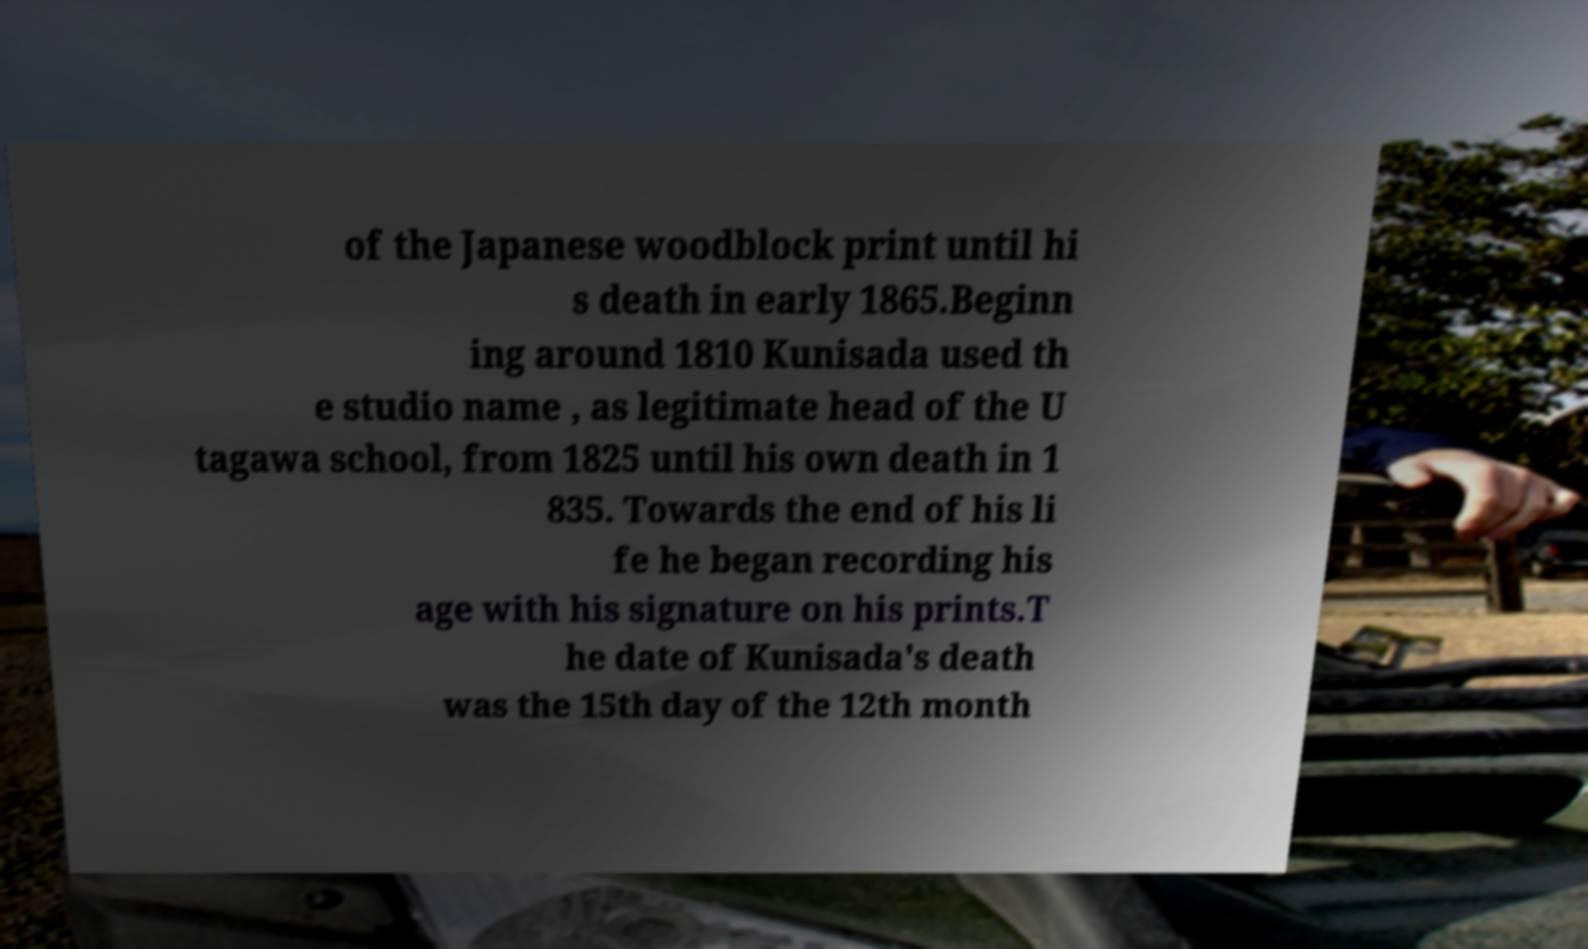What messages or text are displayed in this image? I need them in a readable, typed format. of the Japanese woodblock print until hi s death in early 1865.Beginn ing around 1810 Kunisada used th e studio name , as legitimate head of the U tagawa school, from 1825 until his own death in 1 835. Towards the end of his li fe he began recording his age with his signature on his prints.T he date of Kunisada's death was the 15th day of the 12th month 